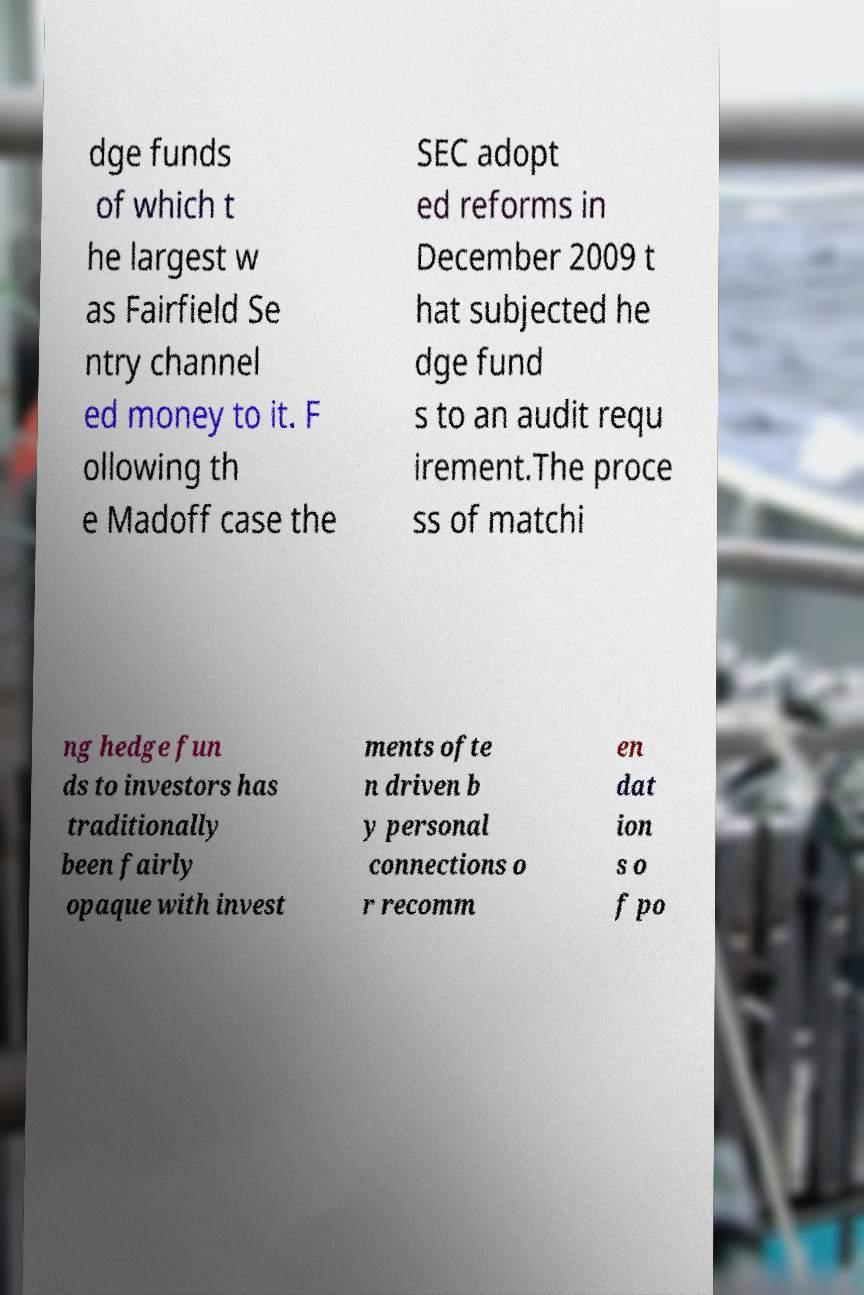Can you read and provide the text displayed in the image?This photo seems to have some interesting text. Can you extract and type it out for me? dge funds of which t he largest w as Fairfield Se ntry channel ed money to it. F ollowing th e Madoff case the SEC adopt ed reforms in December 2009 t hat subjected he dge fund s to an audit requ irement.The proce ss of matchi ng hedge fun ds to investors has traditionally been fairly opaque with invest ments ofte n driven b y personal connections o r recomm en dat ion s o f po 